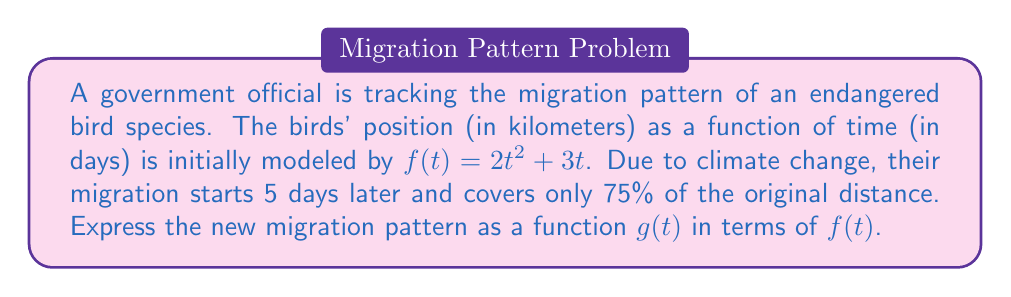Can you solve this math problem? To model the new migration pattern, we need to apply two transformations to the original function $f(t)$:

1. Horizontal shift: The migration starts 5 days later, so we need to replace $t$ with $(t-5)$ in the original function.

2. Vertical compression: The distance covered is reduced to 75% of the original, so we need to multiply the function by 0.75.

Let's apply these transformations step by step:

Step 1: Horizontal shift
$$f(t-5)$$

Step 2: Vertical compression
$$0.75 \cdot f(t-5)$$

Therefore, the new function $g(t)$ can be expressed as:

$$g(t) = 0.75 \cdot f(t-5)$$

This composition of transformations accurately models the new migration pattern of the endangered bird species, taking into account the delayed start and reduced distance due to climate change.
Answer: $g(t) = 0.75 \cdot f(t-5)$ 